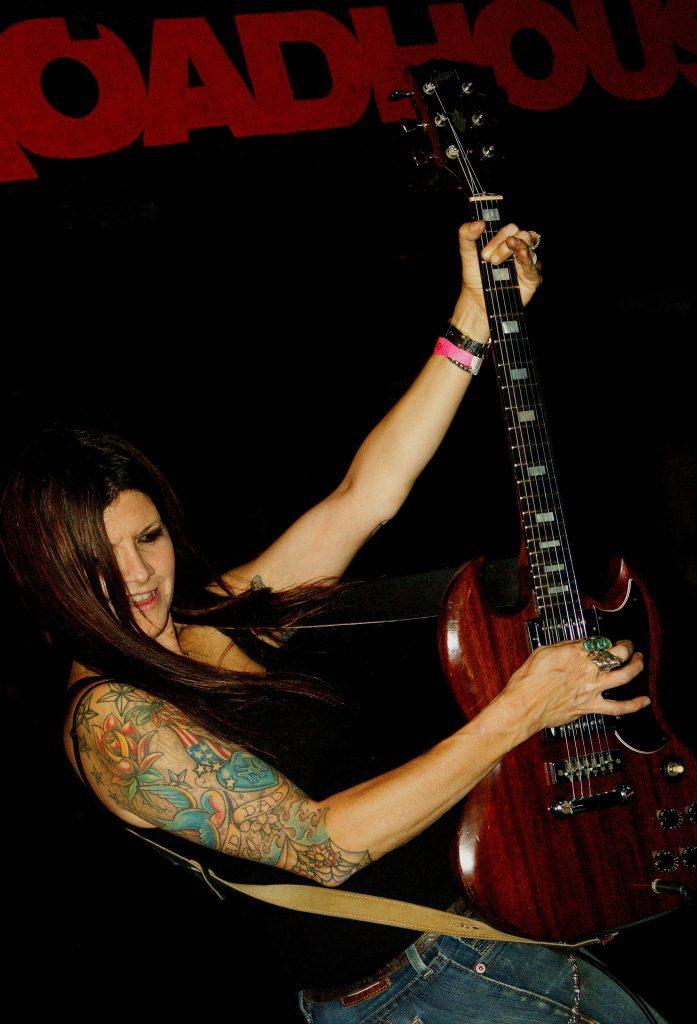Who is the main subject in the image? There is a woman in the image. What is the woman holding in the image? The woman is holding a guitar. What is the woman doing with the guitar? The woman is playing the guitar. What can be seen in the background of the image? There is a board visible in the background of the image. What type of potato is the woman using to play the guitar in the image? There is no potato present in the image, and the woman is using a guitar to play music. 